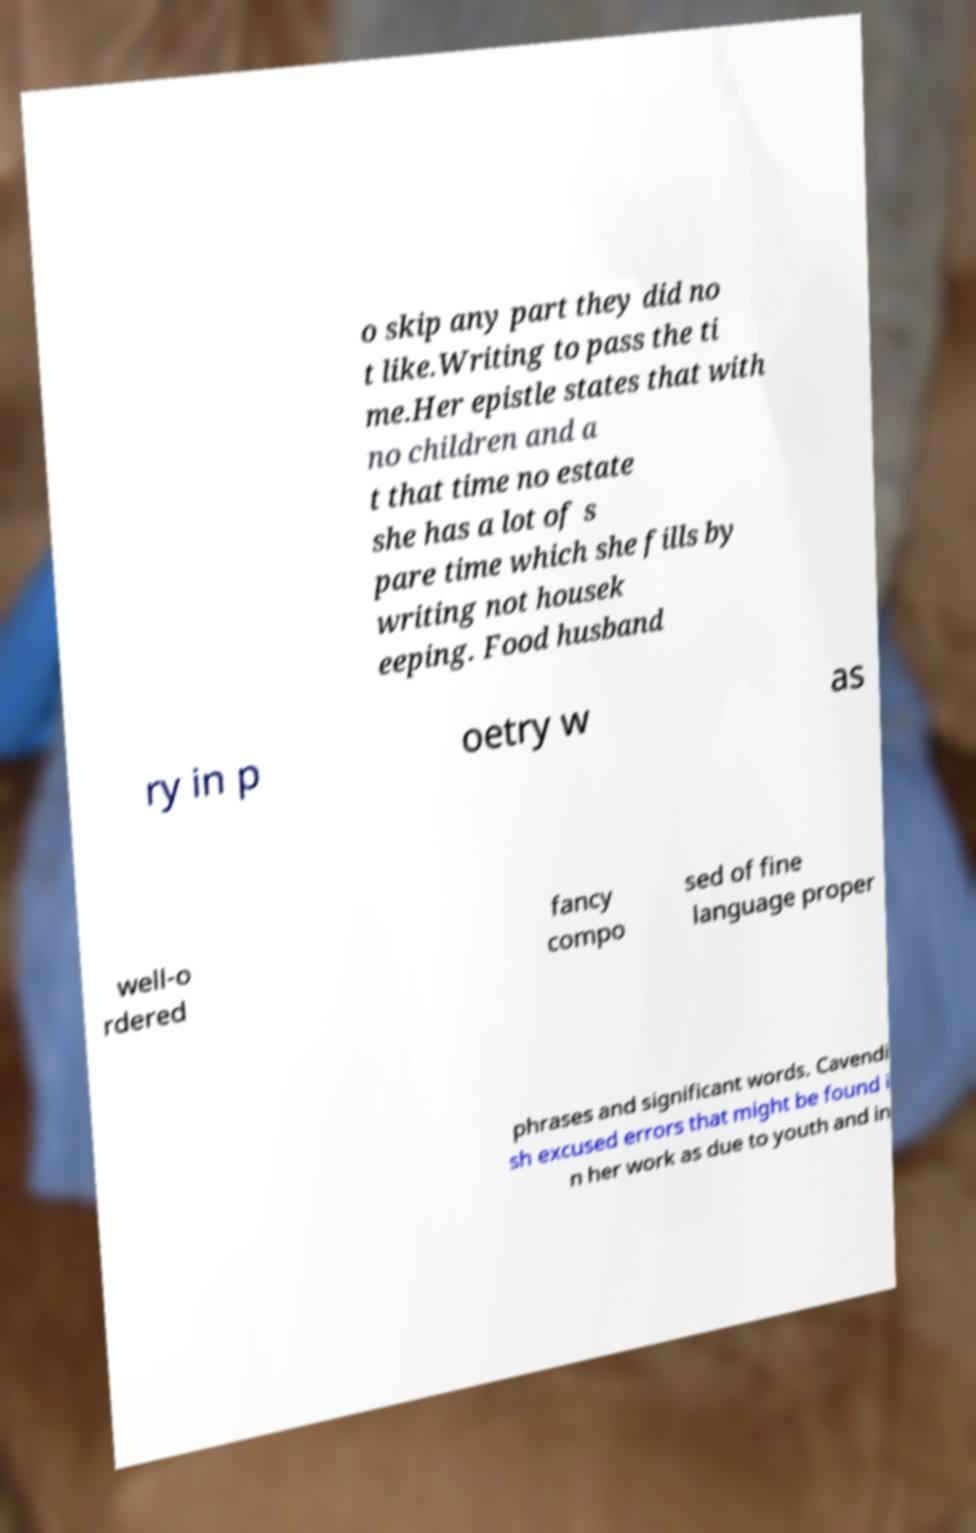Could you assist in decoding the text presented in this image and type it out clearly? o skip any part they did no t like.Writing to pass the ti me.Her epistle states that with no children and a t that time no estate she has a lot of s pare time which she fills by writing not housek eeping. Food husband ry in p oetry w as well-o rdered fancy compo sed of fine language proper phrases and significant words. Cavendi sh excused errors that might be found i n her work as due to youth and in 